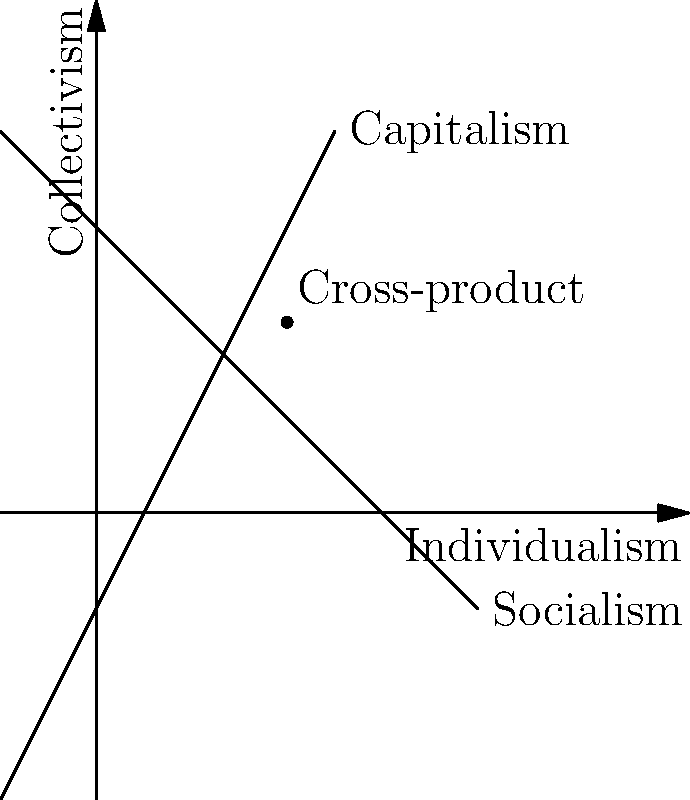In the context of conflicting ideologies represented as vectors, consider capitalism and socialism plotted on a 2D plane where the x-axis represents individualism and the y-axis represents collectivism. If capitalism is represented by the vector $\vec{a} = (3, 5)$ and socialism by $\vec{b} = (1, 7)$, what is the magnitude of their cross-product $|\vec{a} \times \vec{b}|$, and what does this value signify in terms of ideological conflict? To solve this problem, we need to follow these steps:

1. Recall the formula for the magnitude of the cross-product of two 2D vectors:
   $|\vec{a} \times \vec{b}| = |a_x b_y - a_y b_x|$

2. Identify the components of each vector:
   $\vec{a} = (a_x, a_y) = (3, 5)$
   $\vec{b} = (b_x, b_y) = (1, 7)$

3. Apply the formula:
   $|\vec{a} \times \vec{b}| = |3 \cdot 7 - 5 \cdot 1|$
                             $= |21 - 5|$
                             $= |16|$
                             $= 16$

4. Interpret the result:
   The magnitude of the cross-product (16) represents the area of the parallelogram formed by these two vectors. In the context of ideological conflict, this value can be interpreted as the degree of ideological tension or the extent of philosophical disagreement between capitalism and socialism.

   A larger magnitude indicates a greater degree of conflict or divergence between the ideologies, while a smaller magnitude would suggest more alignment or similarity.

5. Consider the philosophical implications:
   This mathematical representation allows for a quantitative analysis of ideological differences, which can be useful in comparative political philosophy and sociological studies. However, it's important to note that this is a simplified model and real-world ideological conflicts are multidimensional and more complex.
Answer: 16; represents the degree of ideological tension between capitalism and socialism 